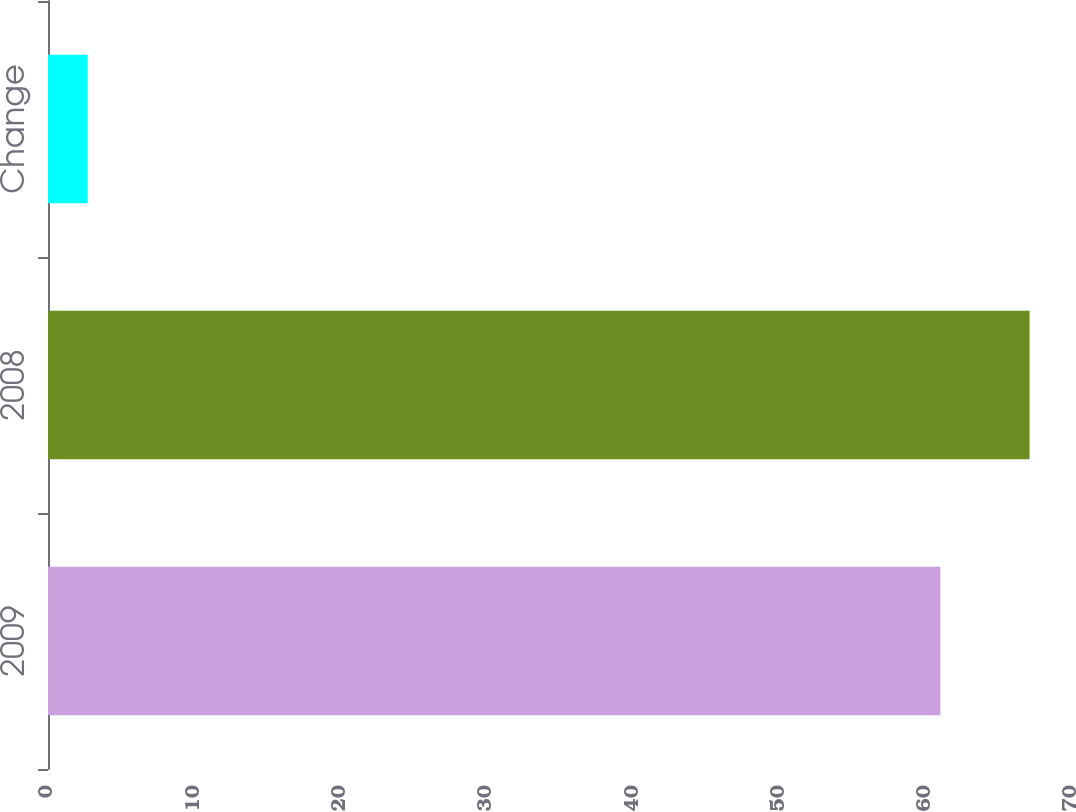Convert chart. <chart><loc_0><loc_0><loc_500><loc_500><bar_chart><fcel>2009<fcel>2008<fcel>Change<nl><fcel>61<fcel>67.1<fcel>2.7<nl></chart> 